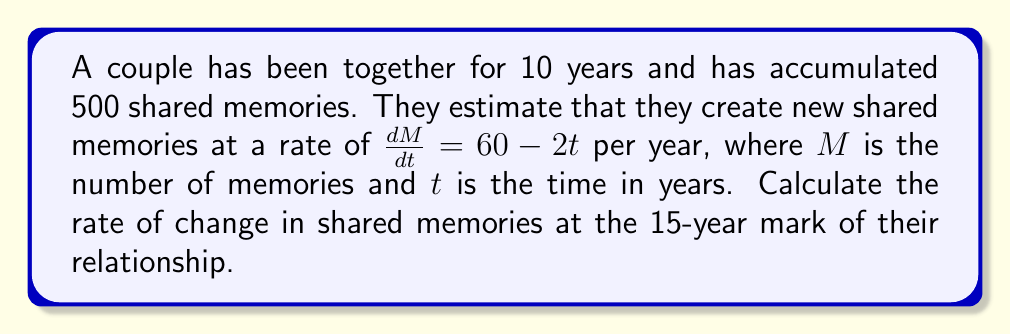Give your solution to this math problem. To solve this problem, we need to follow these steps:

1. Identify the given information:
   - The rate of change in memories is given by the function $\frac{dM}{dt} = 60 - 2t$
   - We need to find the rate of change at $t = 15$ years

2. Substitute $t = 15$ into the rate of change function:

   $$\frac{dM}{dt} = 60 - 2t$$
   $$\frac{dM}{dt} = 60 - 2(15)$$

3. Simplify the expression:

   $$\frac{dM}{dt} = 60 - 30$$
   $$\frac{dM}{dt} = 30$$

4. Interpret the result:
   The rate of change in shared memories at the 15-year mark is 30 memories per year.
Answer: 30 memories/year 